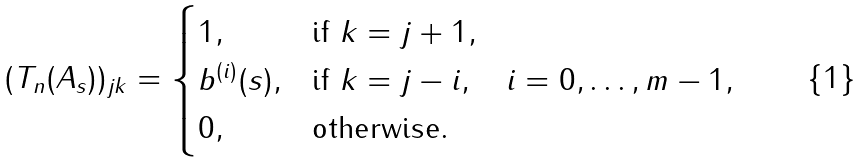Convert formula to latex. <formula><loc_0><loc_0><loc_500><loc_500>( T _ { n } ( A _ { s } ) ) _ { j k } = \begin{cases} 1 , & \text {if } k = j + 1 , \\ b ^ { ( i ) } ( s ) , & \text {if } k = j - i , \quad i = 0 , \dots , m - 1 , \\ 0 , & \text {otherwise} . \end{cases}</formula> 